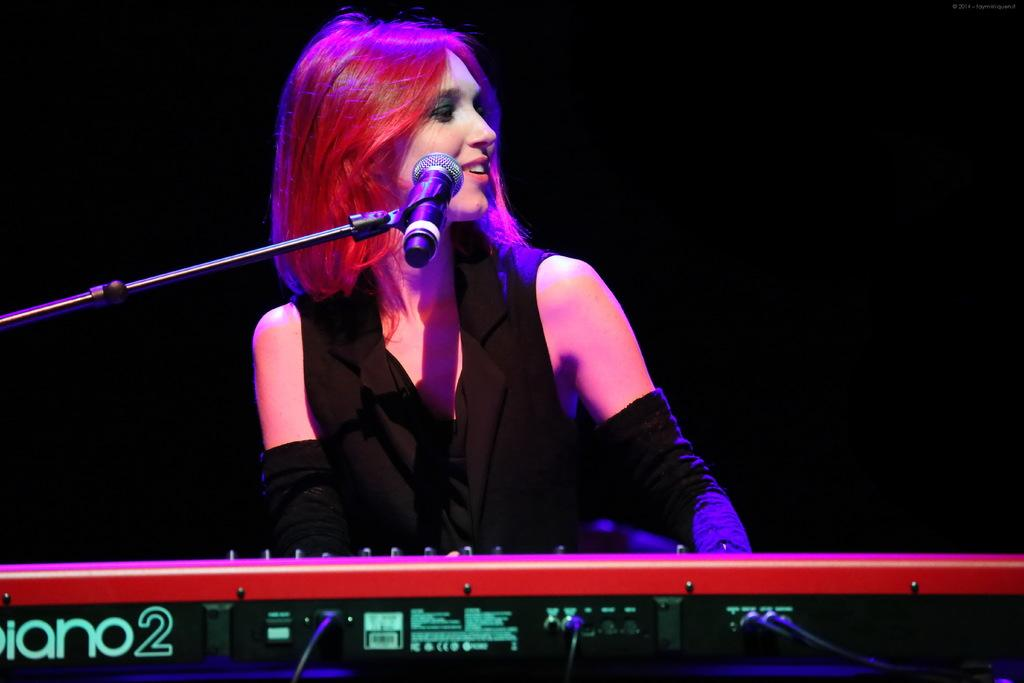What is the main subject of the image? The main subject of the image is a woman. What is the woman wearing in the image? The woman is wearing a black top in the image. What activity is the woman engaged in? The woman is playing the piano in the image. In which direction is the woman looking? The woman is looking to the right side in the image. What can be observed about the background of the image? The background of the image is dark. What type of punishment is the woman receiving in the image? There is no indication of punishment in the image; the woman is playing the piano. Can you see any worms crawling on the piano in the image? There are no worms present in the image; the woman is playing the piano in a dark background. 